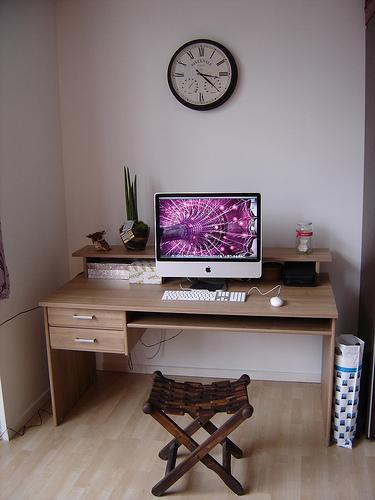What time does the black-framed clock on the wall show? The time on the clock is twenty-two after three. Please describe the flooring in the room. The floor is made from beautiful light brown wood. What type of plant is there in a pot, and where is it located? There is a small mother's tongue plant in a round pot on the desk, providing greenery. Enumerate three items that are found on top of the desk. A computer monitor with a colorful display, a jar filled with shells, and two boxes are on the desk. List down the computer accessories on the desk. A computer keyboard and mouse can be found on the desk. Describe the bag by the desk and where it's positioned. A white bag with blue and black checkers is sitting next to the desk. What kind of figure or figurine can be found beside the cactus? A little brown and white owl statue or figurine is beside the cactus. Can you tell me about the seating arrangement in front of the desk? There is a wooden stool and an uncomfortable folding chair made of real wood in front of the desk. Explain the design on the computer monitor. The computer monitor displays a trippy, colorful design, possibly a screen saver. What can you tell me about the storage features on the desk? The desk has two drawers with silver handles for storing items. 